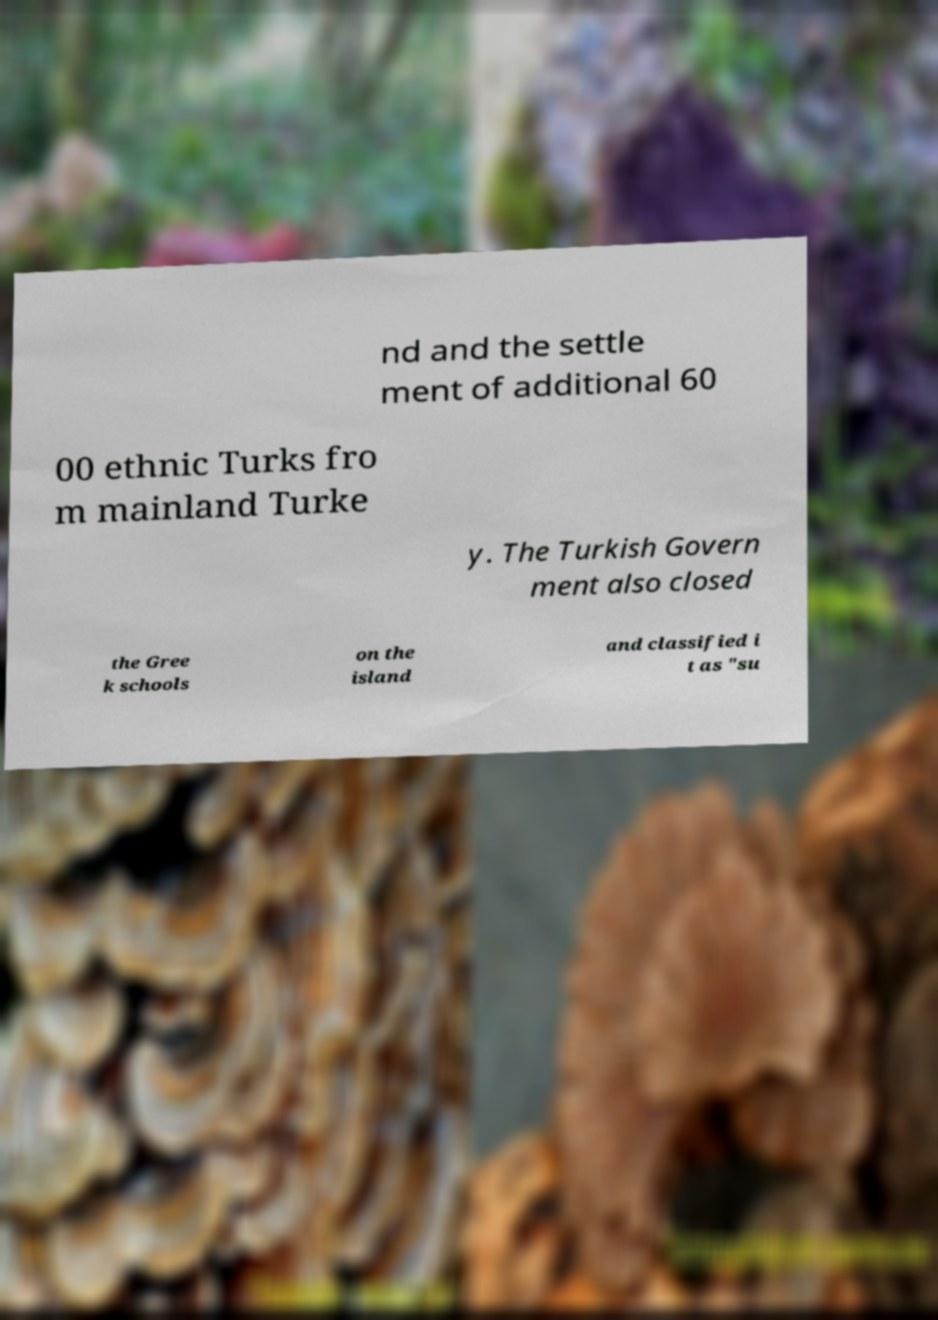Could you extract and type out the text from this image? nd and the settle ment of additional 60 00 ethnic Turks fro m mainland Turke y. The Turkish Govern ment also closed the Gree k schools on the island and classified i t as "su 